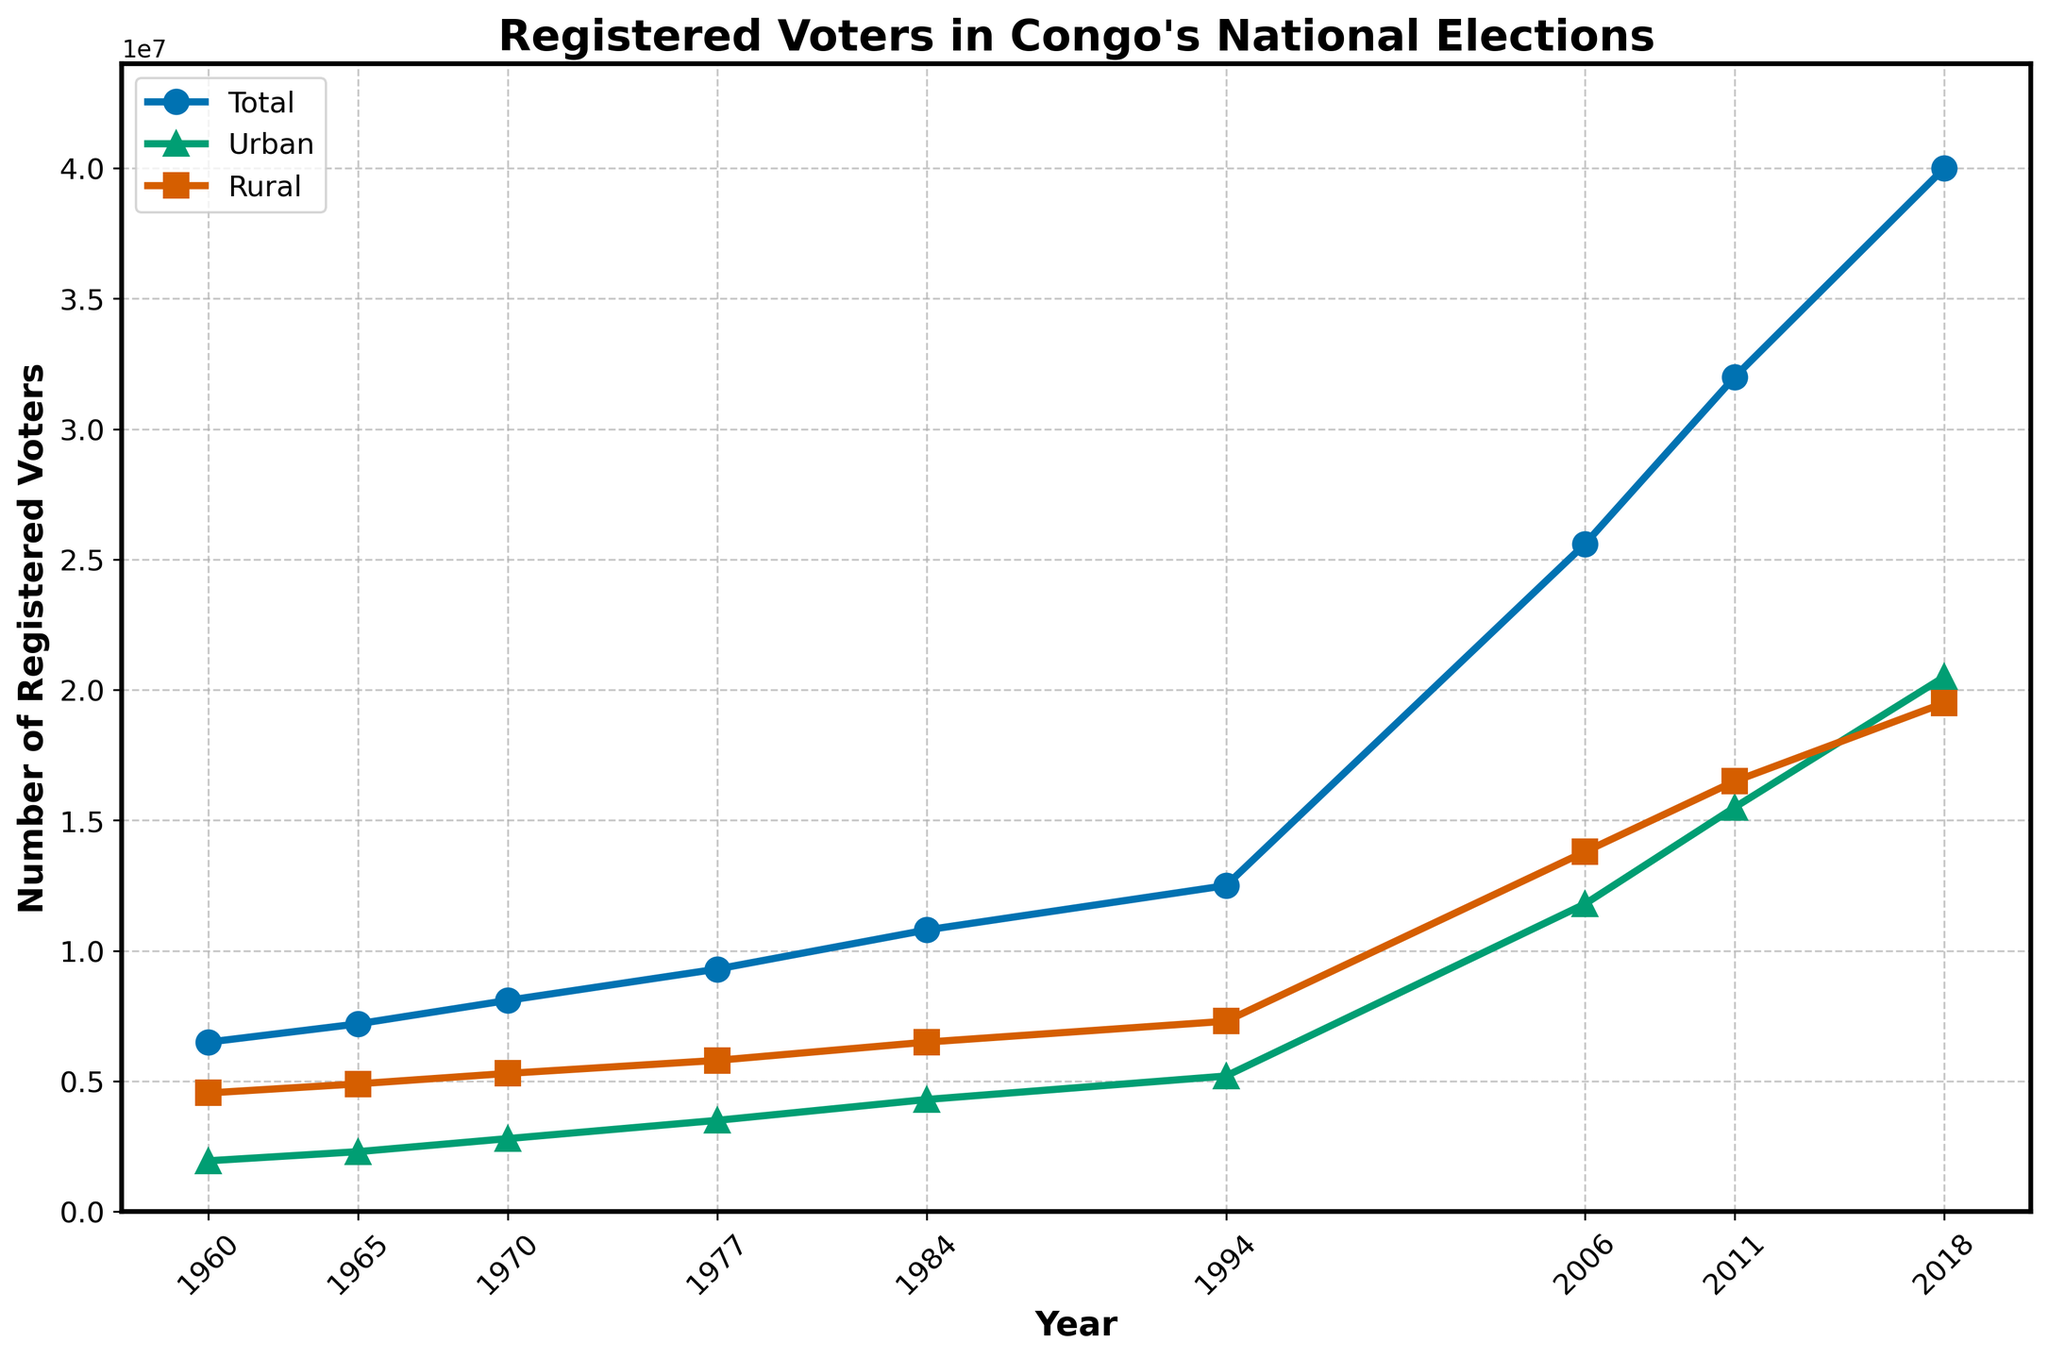What is the difference in the number of registered urban voters between 2018 and 2006? The number of registered urban voters in 2018 is 20,500,000, and in 2006 it is 11,800,000. Subtract 11,800,000 from 20,500,000 to find the difference.
Answer: 8,700,000 Which year had the highest number of registered rural voters? By looking at the figure, the year with the highest number of registered rural voters is 2018, where the registered rural voters are 19,500,000.
Answer: 2018 What is the trend in the number of registered total voters from 1960 to 2018? The number of registered total voters consistently increases from 6,500,000 in 1960 to 40,000,000 in 2018, indicating an upward trend throughout the years.
Answer: Increase By how much did the total number of registered voters increase from 1960 to 1994? The total number of registered voters in 1960 was 6,500,000, and in 1994 it was 12,500,000. The increase is 12,500,000 - 6,500,000.
Answer: 6,000,000 How did the number of registered rural voters change between 1970 and 1984? The number of registered rural voters in 1970 was 5,300,000, and in 1984 it was 6,500,000. The number increased by 6,500,000 - 5,300,000.
Answer: 1,200,000 What is the ratio of registered urban voters to rural voters in the year 2006? In 2006, the number of urban voters is 11,800,000, and rural voters is 13,800,000. The ratio is calculated as 11,800,000 / 13,800,000.
Answer: 0.86 In which year did the registered urban voters exceed 10 million for the first time? Registered urban voters first exceeded 10 million in the year 2006, where the count is 11,800,000.
Answer: 2006 During which period was the growth in registered rural voters the smallest? To find the period with the smallest growth, calculate the difference in registered rural voters between consecutive periods and compare. The smallest growth is from 1977 (5,800,000) to 1984 (6,500,000), which is 6,500,000 - 5,800,000.
Answer: 1977-1984 Compare the rate of increase in urban voters from 2006 to 2011 with the rate of increase from 2011 to 2018. From 2006 to 2011: (15,500,000 - 11,800,000) / 5 = 740,000 voters/year. From 2011 to 2018: (20,500,000 - 15,500,000) / 7 = 714,286 voters/year.
Answer: 2006-2011: 740,000 voters/year, 2011-2018: 714,286 voters/year 